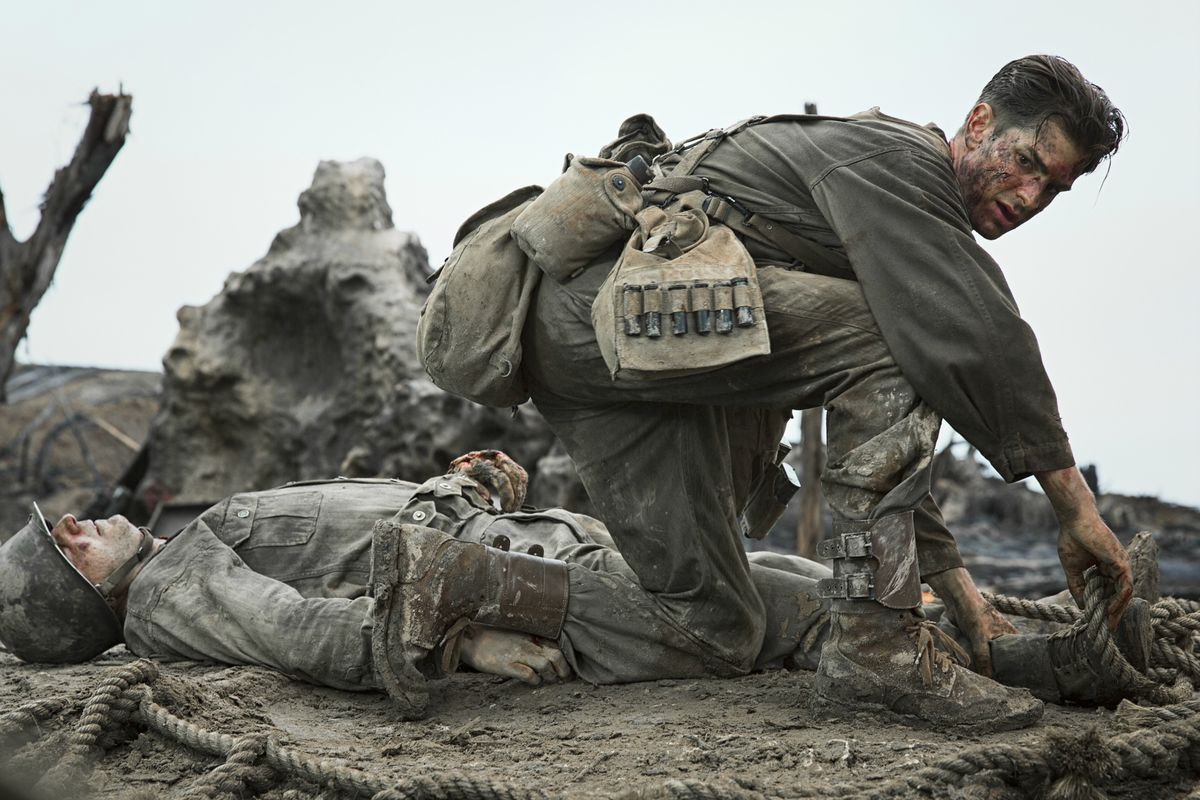Given the context of the scene, what might be some challenges Desmond Doss is facing? Desmond Doss faces several significant challenges in this scene. Firstly, the battlefield setting is fraught with danger, making it difficult to move safely and attend to the wounded. The injuries of the soldiers are likely severe, requiring immediate and skilled medical attention, which adds pressure on him to act swiftly and effectively. Additionally, he must carry and manage his medical supplies efficiently amidst the chaos. Psychological challenges also loom large; the stress of witnessing the suffering and potential death of comrades, coupled with the noise and confusion of battle, tests his mental resilience and focus. 